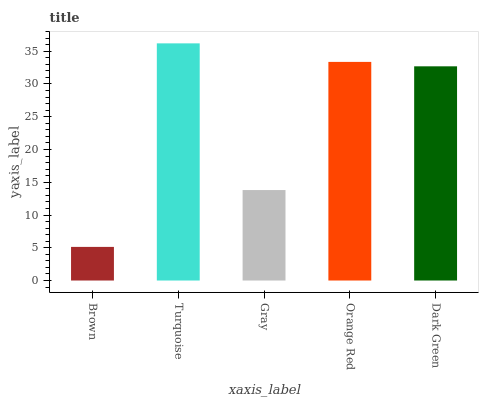Is Brown the minimum?
Answer yes or no. Yes. Is Turquoise the maximum?
Answer yes or no. Yes. Is Gray the minimum?
Answer yes or no. No. Is Gray the maximum?
Answer yes or no. No. Is Turquoise greater than Gray?
Answer yes or no. Yes. Is Gray less than Turquoise?
Answer yes or no. Yes. Is Gray greater than Turquoise?
Answer yes or no. No. Is Turquoise less than Gray?
Answer yes or no. No. Is Dark Green the high median?
Answer yes or no. Yes. Is Dark Green the low median?
Answer yes or no. Yes. Is Gray the high median?
Answer yes or no. No. Is Gray the low median?
Answer yes or no. No. 